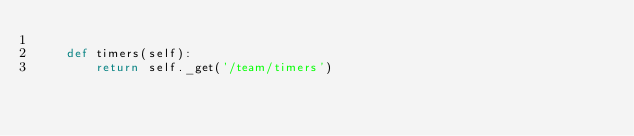Convert code to text. <code><loc_0><loc_0><loc_500><loc_500><_Python_>
    def timers(self):
        return self._get('/team/timers')
</code> 